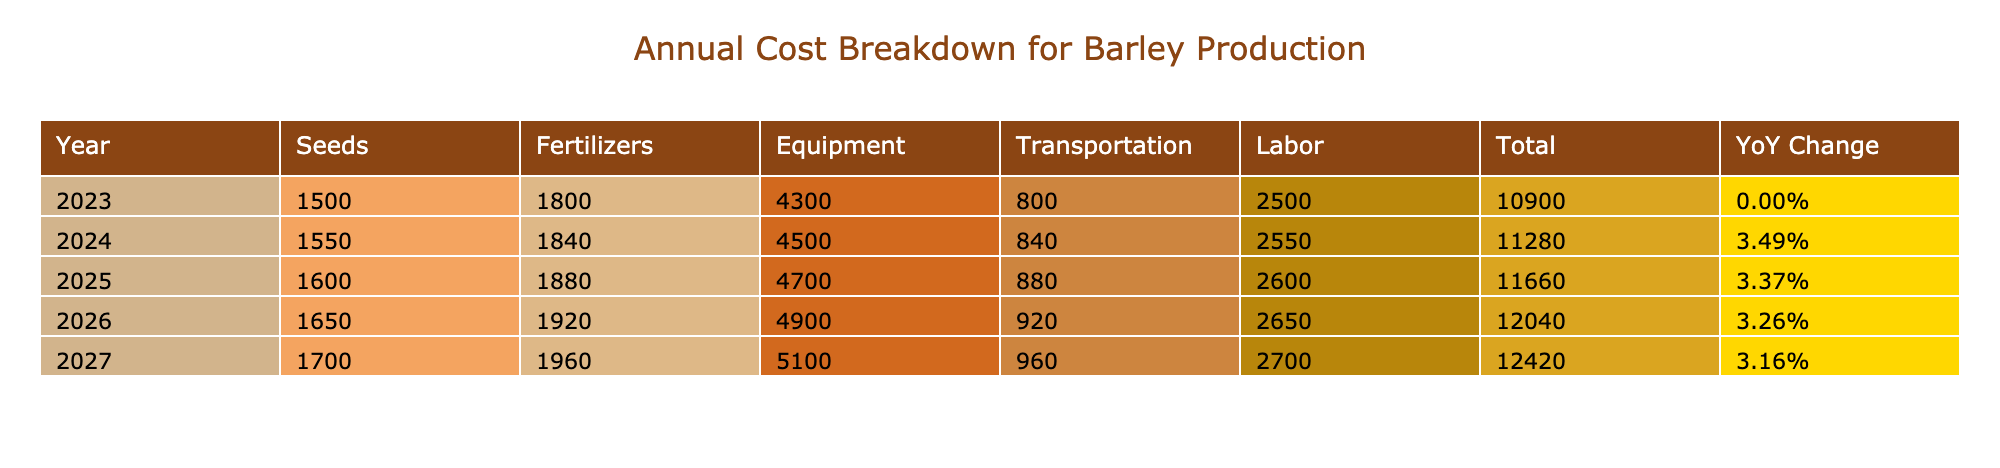What was the total cost of labor for 2023? The total cost for labor in 2023 is found under the 'Labor' category for that year, which is 2500 GBP.
Answer: 2500 GBP What category had the highest total cost in 2024? To find this, we check the sum of costs for each category in 2024. The costs are: Seeds 1550, Fertilizers 1840, Equipment 4550, Transportation 840, and Labor 2550. The Equipment category has the highest value at 4550 GBP.
Answer: Equipment What is the average cost of fertilizers over the years? We sum the total costs for fertilizers across all years: 800 + 600 + 400 + 820 + 610 + 410 + 840 + 630 + 430 + 880 + 640 = 8000 GBP. There are 11 data points, so the average is 8000/11 ≈ 727.27 GBP.
Answer: 727.27 GBP Did the cost of barley seeds increase every year? We examine the costs of barley seeds for each year: 1500, 1550, 1600, 1650, 1700. Each value is greater than the previous one, confirming the increase occurred each year.
Answer: Yes How much was spent on transportation in 2025 compared to 2026? For 2025, the total transportation cost is Fuel 540 + Truck Maintenance 340 = 880 GBP. For 2026, it is Fuel 560 + Truck Maintenance 360 = 920 GBP. Since 920 GBP (2026) is greater than 880 GBP (2025), we conclude there was an increase.
Answer: Increase What was the year-over-year change in total costs from 2026 to 2027? First, we find the total costs for each year: total for 2026 is 19,270 GBP and for 2027 is 20,400 GBP. The change is (20,400 - 19,270)/19,270 = 5.93%. Hence, the year-over-year change is approximately 5.93%.
Answer: 5.93% What is the total cost of equipment for the years combined? The total equipment costs are obtained by adding all the costs in the Equipment category across years: 1200 + 900 + 1500 + 700 + 1250 + 950 + 1550 + 750 + 5400 + 800 + 580 + 380 = 19860 GBP.
Answer: 19860 GBP Was the cost for Nitrogen fertilizer less than that for Phosphate fertilizer in any year? We look at the costs for Nitrogen and Phosphate fertilizers across the years: 800 vs 600 in 2023, 820 vs 610 in 2024, 840 vs 620 in 2025, 860 vs 630 in 2026, and 880 vs 640 in 2027. In every year, Nitrogen fertilizer costs are higher than Phosphate fertilizer.
Answer: No 